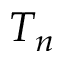Convert formula to latex. <formula><loc_0><loc_0><loc_500><loc_500>T _ { n }</formula> 